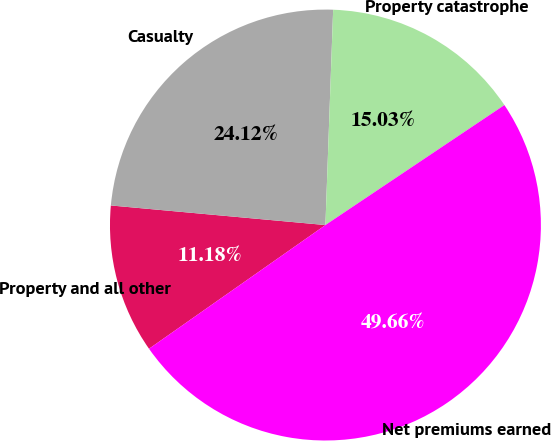Convert chart to OTSL. <chart><loc_0><loc_0><loc_500><loc_500><pie_chart><fcel>Property and all other<fcel>Casualty<fcel>Property catastrophe<fcel>Net premiums earned<nl><fcel>11.18%<fcel>24.12%<fcel>15.03%<fcel>49.66%<nl></chart> 